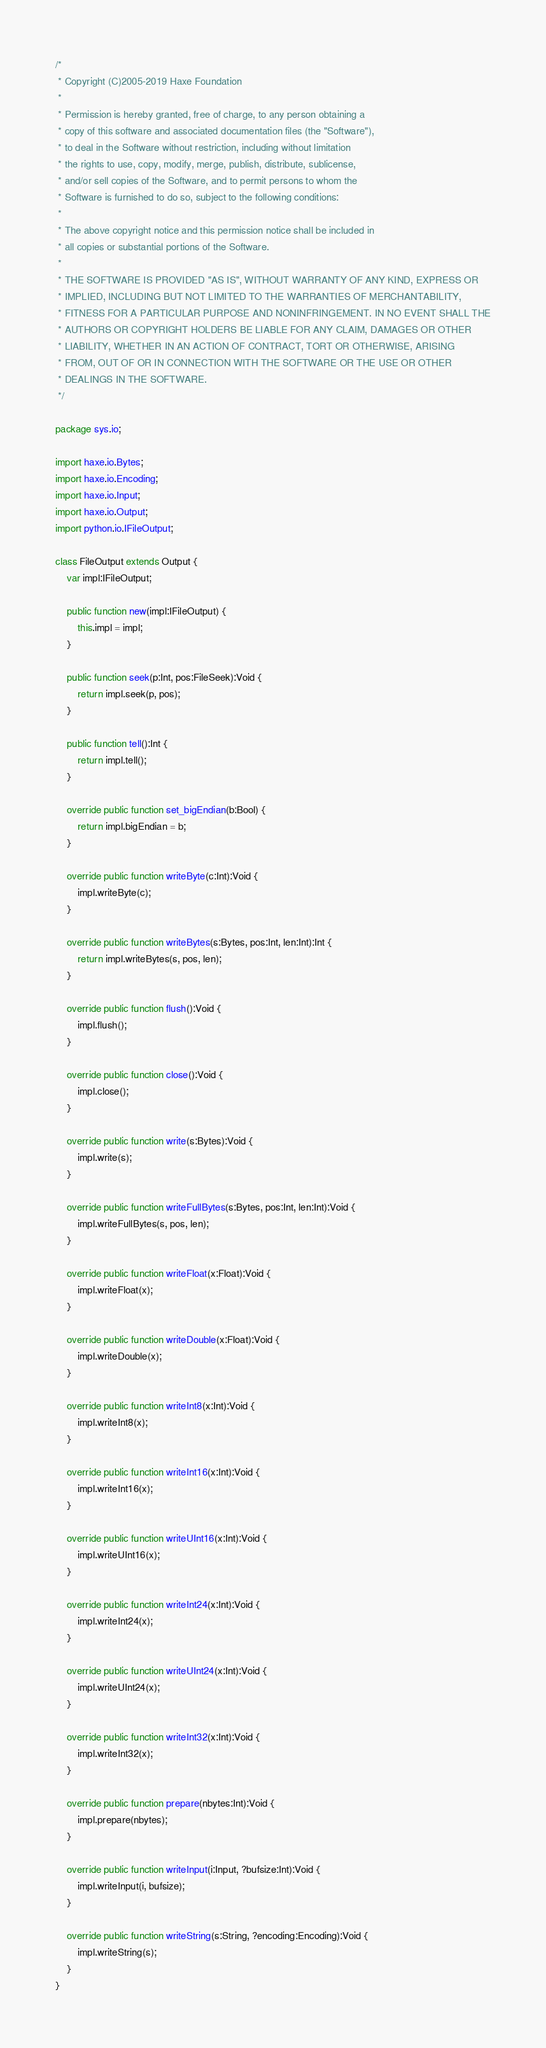<code> <loc_0><loc_0><loc_500><loc_500><_Haxe_>/*
 * Copyright (C)2005-2019 Haxe Foundation
 *
 * Permission is hereby granted, free of charge, to any person obtaining a
 * copy of this software and associated documentation files (the "Software"),
 * to deal in the Software without restriction, including without limitation
 * the rights to use, copy, modify, merge, publish, distribute, sublicense,
 * and/or sell copies of the Software, and to permit persons to whom the
 * Software is furnished to do so, subject to the following conditions:
 *
 * The above copyright notice and this permission notice shall be included in
 * all copies or substantial portions of the Software.
 *
 * THE SOFTWARE IS PROVIDED "AS IS", WITHOUT WARRANTY OF ANY KIND, EXPRESS OR
 * IMPLIED, INCLUDING BUT NOT LIMITED TO THE WARRANTIES OF MERCHANTABILITY,
 * FITNESS FOR A PARTICULAR PURPOSE AND NONINFRINGEMENT. IN NO EVENT SHALL THE
 * AUTHORS OR COPYRIGHT HOLDERS BE LIABLE FOR ANY CLAIM, DAMAGES OR OTHER
 * LIABILITY, WHETHER IN AN ACTION OF CONTRACT, TORT OR OTHERWISE, ARISING
 * FROM, OUT OF OR IN CONNECTION WITH THE SOFTWARE OR THE USE OR OTHER
 * DEALINGS IN THE SOFTWARE.
 */

package sys.io;

import haxe.io.Bytes;
import haxe.io.Encoding;
import haxe.io.Input;
import haxe.io.Output;
import python.io.IFileOutput;

class FileOutput extends Output {
	var impl:IFileOutput;

	public function new(impl:IFileOutput) {
		this.impl = impl;
	}

	public function seek(p:Int, pos:FileSeek):Void {
		return impl.seek(p, pos);
	}

	public function tell():Int {
		return impl.tell();
	}

	override public function set_bigEndian(b:Bool) {
		return impl.bigEndian = b;
	}

	override public function writeByte(c:Int):Void {
		impl.writeByte(c);
	}

	override public function writeBytes(s:Bytes, pos:Int, len:Int):Int {
		return impl.writeBytes(s, pos, len);
	}

	override public function flush():Void {
		impl.flush();
	}

	override public function close():Void {
		impl.close();
	}

	override public function write(s:Bytes):Void {
		impl.write(s);
	}

	override public function writeFullBytes(s:Bytes, pos:Int, len:Int):Void {
		impl.writeFullBytes(s, pos, len);
	}

	override public function writeFloat(x:Float):Void {
		impl.writeFloat(x);
	}

	override public function writeDouble(x:Float):Void {
		impl.writeDouble(x);
	}

	override public function writeInt8(x:Int):Void {
		impl.writeInt8(x);
	}

	override public function writeInt16(x:Int):Void {
		impl.writeInt16(x);
	}

	override public function writeUInt16(x:Int):Void {
		impl.writeUInt16(x);
	}

	override public function writeInt24(x:Int):Void {
		impl.writeInt24(x);
	}

	override public function writeUInt24(x:Int):Void {
		impl.writeUInt24(x);
	}

	override public function writeInt32(x:Int):Void {
		impl.writeInt32(x);
	}

	override public function prepare(nbytes:Int):Void {
		impl.prepare(nbytes);
	}

	override public function writeInput(i:Input, ?bufsize:Int):Void {
		impl.writeInput(i, bufsize);
	}

	override public function writeString(s:String, ?encoding:Encoding):Void {
		impl.writeString(s);
	}
}
</code> 